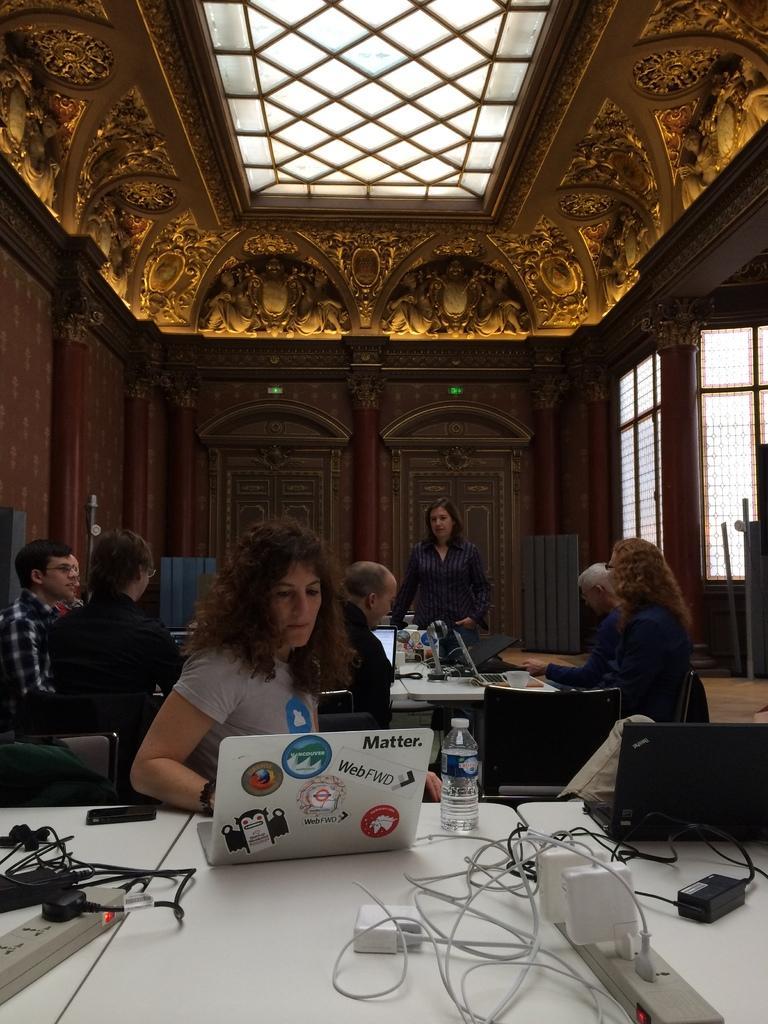How would you summarize this image in a sentence or two? In this image I can see few people are sitting on the chairs and one person is standing. I can see few laptops, bottle, extension-boxes, wires and few objects on the tables. Back I can see few windows and the brown color wall. 